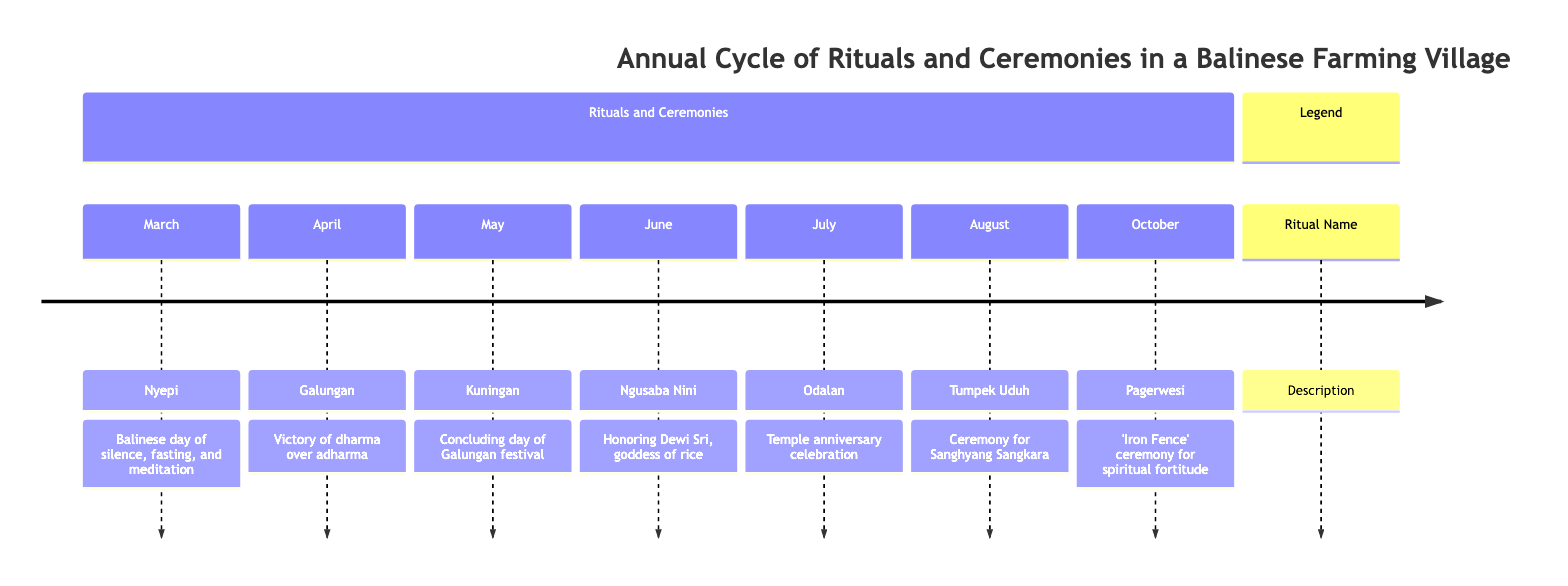What is the first ritual in the timeline? The first ritual listed in the timeline is Nyepi, which occurs in March.
Answer: Nyepi Which month is associated with Odalan? Odalan is associated with the month of July, as indicated in the timeline.
Answer: July How many rituals take place in the month of June? The timeline shows that there is one ritual taking place in June, which is Ngusaba Nini.
Answer: 1 What is celebrated during Galungan? During Galungan, the celebration is for the victory of dharma over adharma.
Answer: Victory of dharma over adharma Which two rituals are celebrated back-to-back in April and May? The two rituals celebrated back-to-back are Galungan in April and Kuningan in May.
Answer: Galungan and Kuningan What is the purpose of the Tumpek Uduh ceremony? The Tumpek Uduh ceremony is dedicated to Sanghyang Sangkara, the god of plants, focusing on making offerings for a good harvest.
Answer: Offerings for a good harvest Which month has a celebration focused on the goddess of rice? The celebration focused on the goddess of rice, Dewi Sri, occurs in June during the Ngusaba Nini ceremony.
Answer: June How many rituals are mentioned in total on the timeline? There are a total of seven rituals mentioned in the timeline that occur throughout the year.
Answer: 7 What type of ceremony is Pagerwesi also known as? Pagerwesi is also known as the 'Iron Fence' ceremony.
Answer: 'Iron Fence' ceremony 